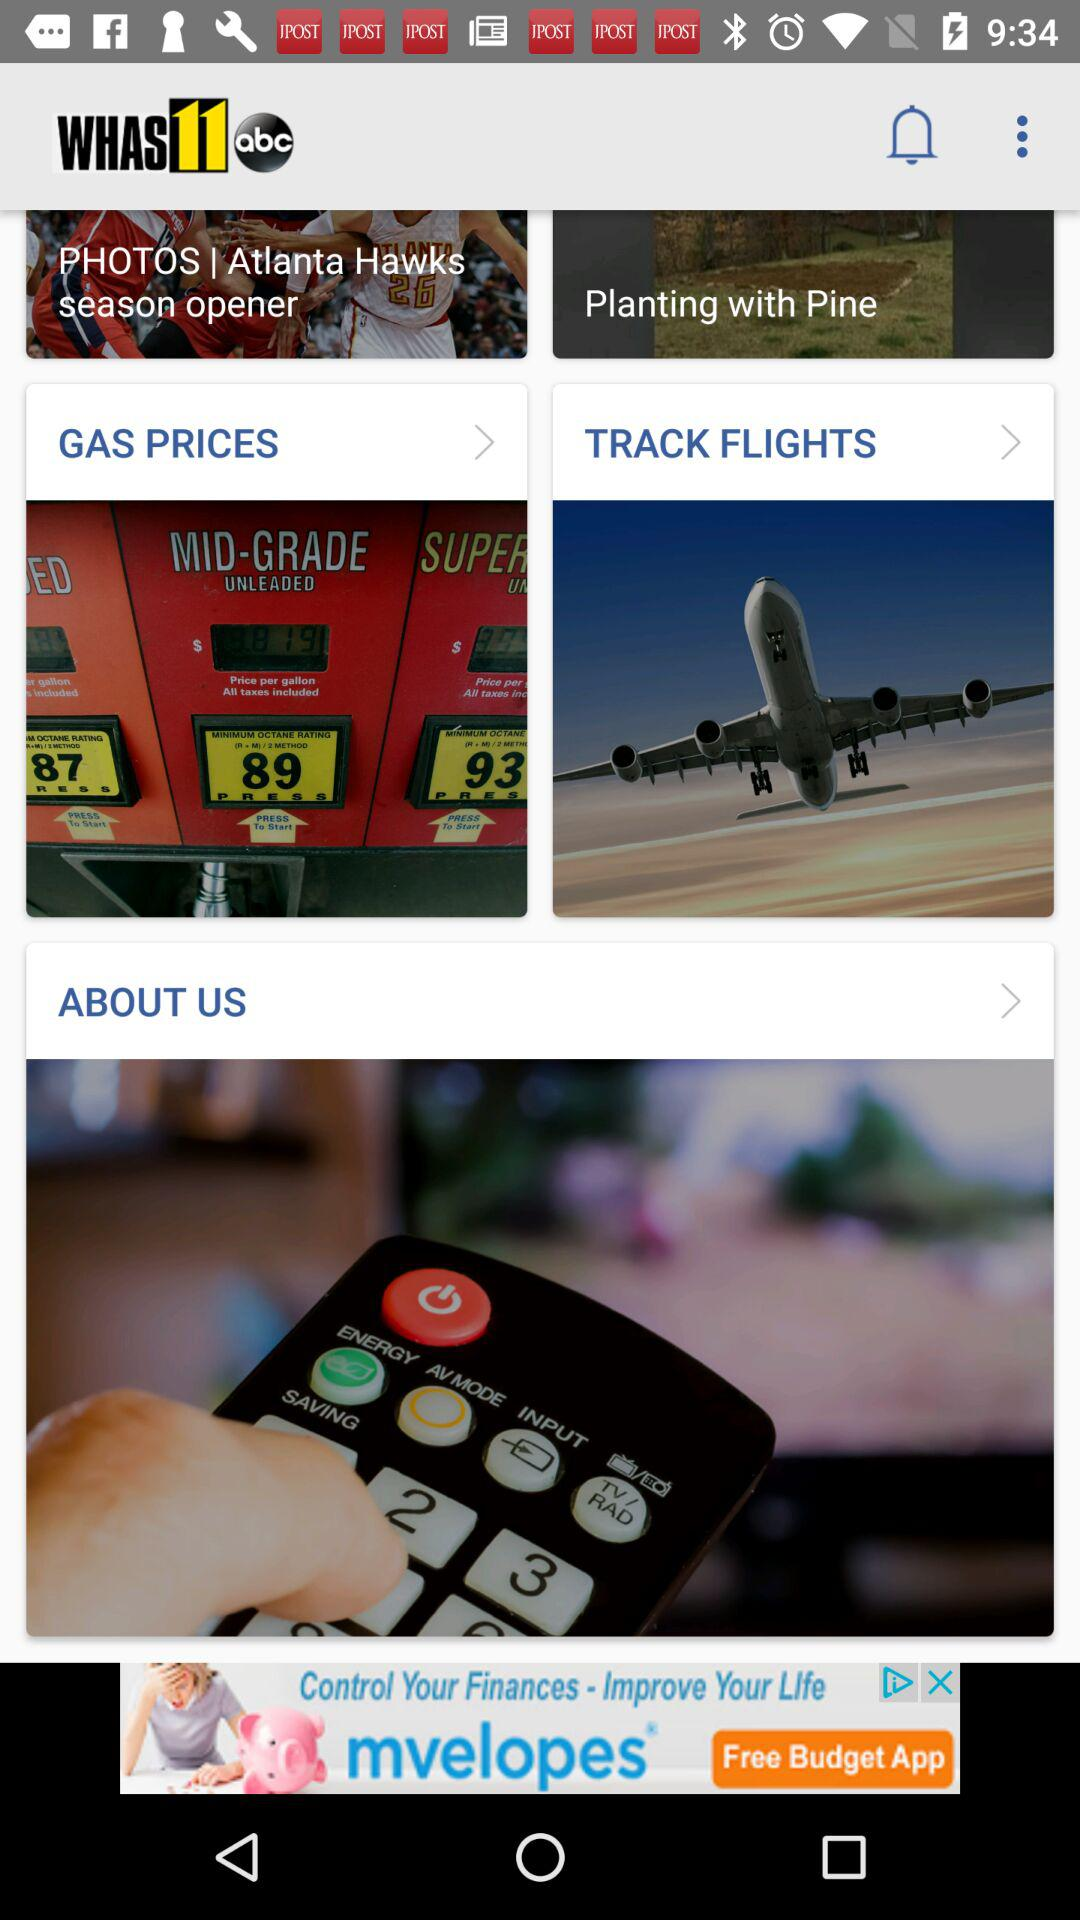What is the name of the application? The name of the application is "WHAS11 abc". 